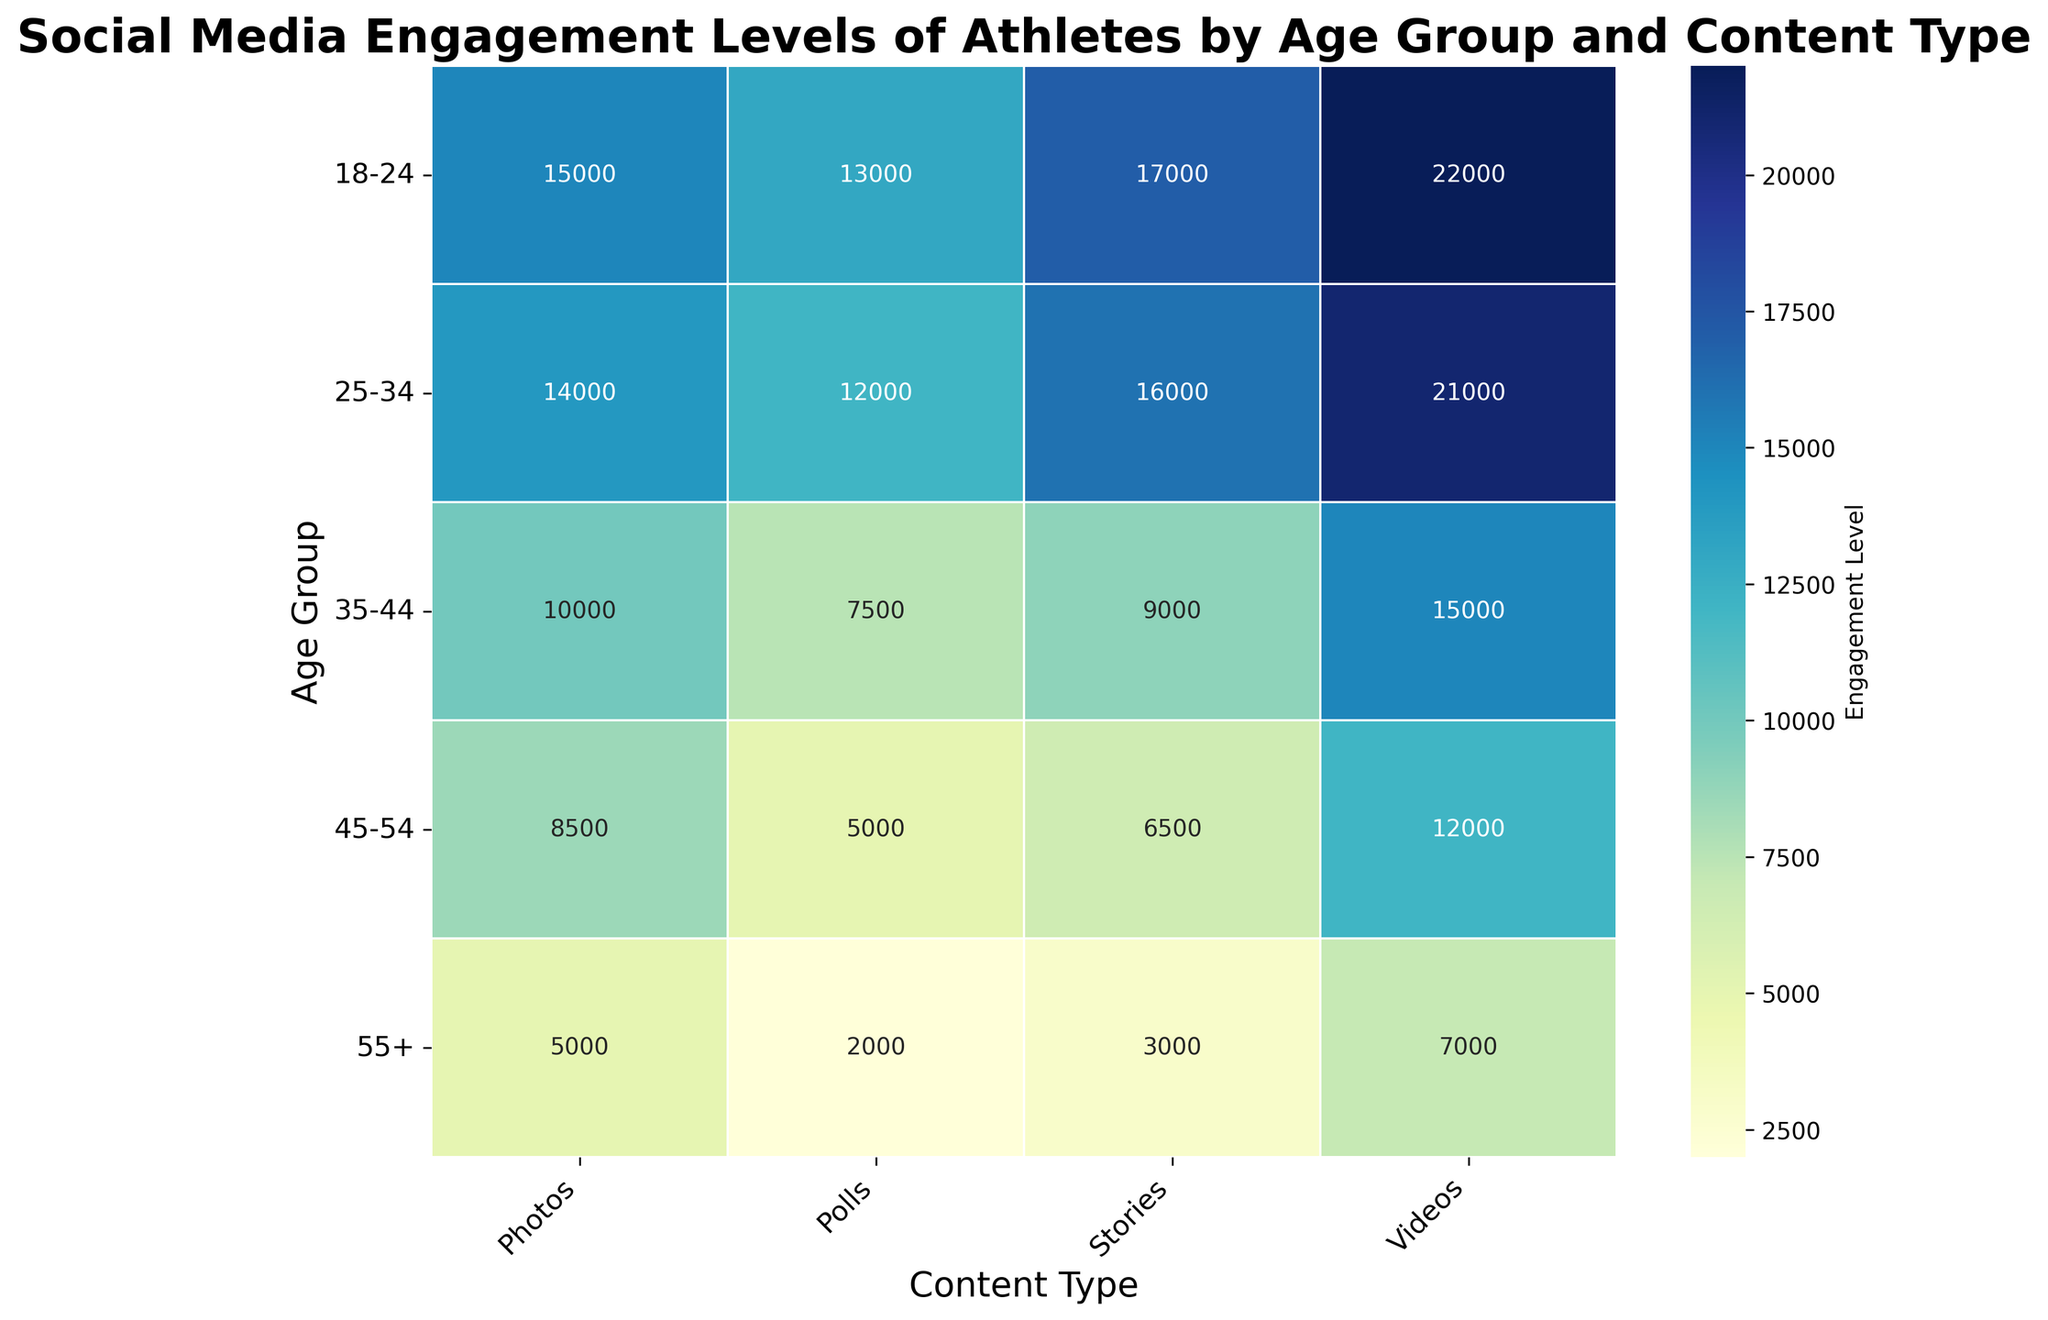What is the engagement level of Photos content for the 18-24 age group? By examining the heatmap, locate the intersection of the "18-24" row and the "Photos" column to find the engagement level.
Answer: 15000 What is the difference in engagement levels between Videos and Polls for the 25-34 age group? Find the engagement levels for "Videos" and "Polls" within the "25-34" age group. Calculate the difference: 21000 (Videos) - 12000 (Polls).
Answer: 9000 Which age group shows the highest engagement level for Stories content? Look at the "Stories" column and compare the values across all age groups. The highest value corresponds to 18-24 age group (17000).
Answer: 18-24 How much more engagement do Photos get compared to Polls across all age groups combined? Sum the engagement levels of Photos (15000 + 14000 + 10000 + 8500 + 5000) and Polls (13000 + 12000 + 7500 + 5000 + 2000) across all age groups. Then find the difference: (15000+14000+10000+8500+5000) - (13000+12000+7500+5000+2000).
Answer: 32500 Which content type has the least engagement for the 55+ age group? Identify the lowest value among the content types for the "55+" age group by examining the heatmap's last row.
Answer: Polls What is the average engagement level for Videos across all age groups? Calculate the average by adding the engagement levels for "Videos" across all age groups (22000 + 21000 + 15000 + 12000 + 7000) and then divide by the number of age groups (5).
Answer: 15400 Compare the engagement levels for Polls between the 18-24 and 45-54 age groups. Which is higher? Refer to the heatmap for Polls in both age groups and compare the values: 13000 (18-24) and 5000 (45-54).
Answer: 18-24 Identify the content type with the most variation in engagement levels across age groups. Evaluate the range of engagement levels for each content type by subtracting the minimum value from the maximum value and identify the content type with the highest range: Videos (22000 - 7000), Photos (15000 - 5000), Stories (17000 - 3000), Polls (13000 - 2000).
Answer: Videos What is the total engagement level for Stories across the 25-34 and 35-44 age groups? Add the engagement levels of "Stories" for these two age groups from the heatmap: 16000 (25-34) + 9000 (35-44).
Answer: 25000 